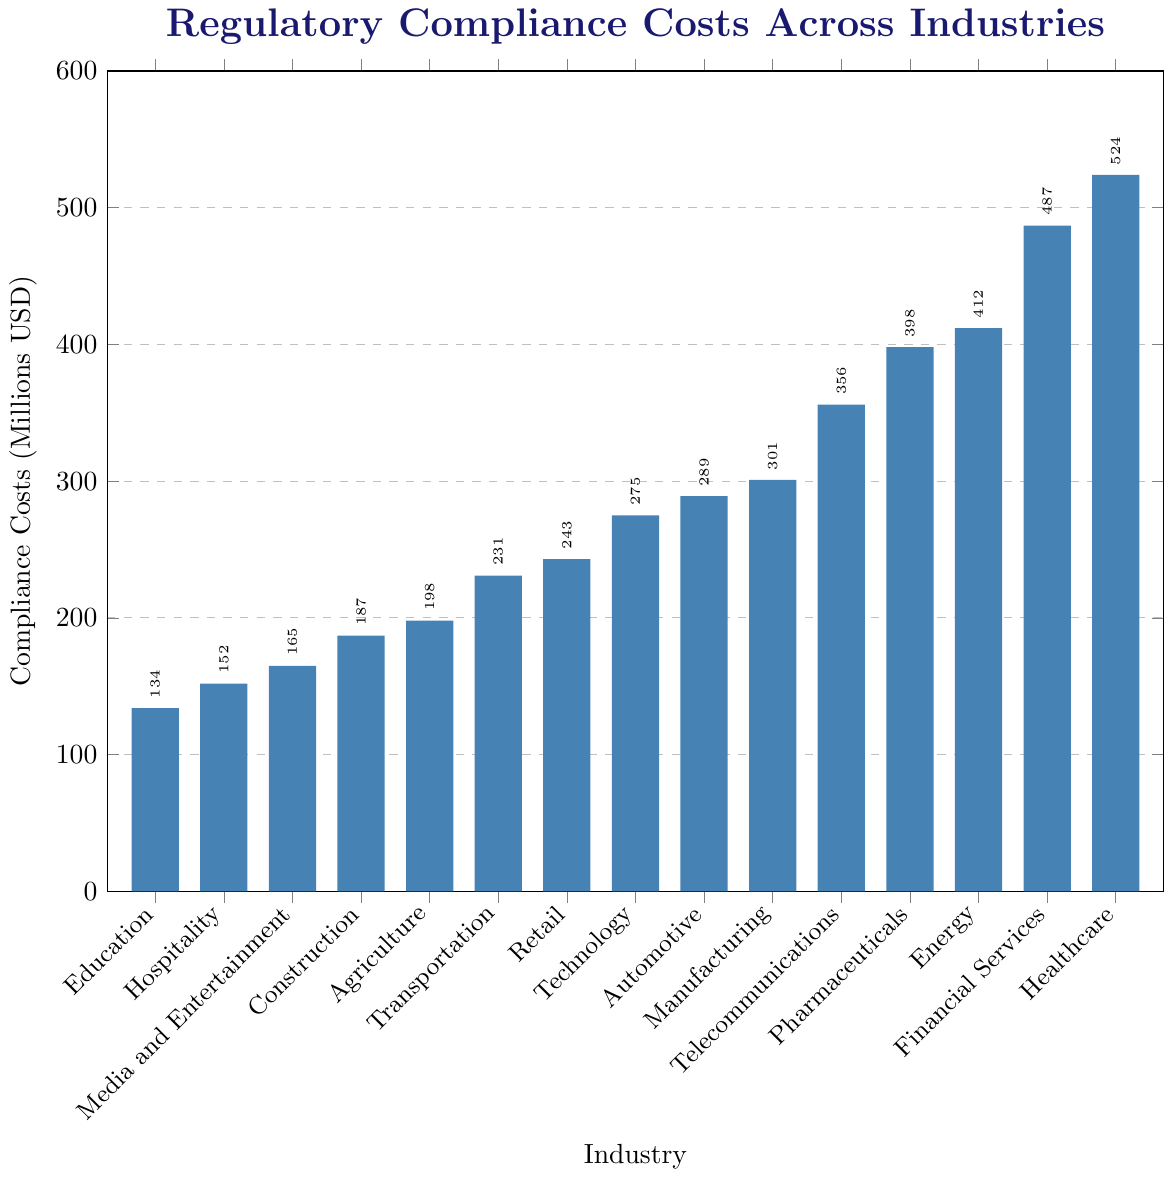Which industry has the highest regulatory compliance cost? The industry with the highest bar represents the highest compliance cost. Based on the chart, the Healthcare industry has the highest bar.
Answer: Healthcare What is the difference in regulatory compliance costs between the Financial Services and Telecommunications industries? The Financial Services industry has a compliance cost of 487 million USD, and the Telecommunications industry has 356 million USD. The difference is 487 - 356 = 131 million USD.
Answer: 131 million USD Which industry has the lowest regulatory compliance cost, and what is its value? The industry with the shortest bar represents the lowest compliance cost. Based on the chart, the Education industry has the lowest bar with a cost of 134 million USD.
Answer: Education with 134 million USD What is the sum of compliance costs for the Energy, Pharmaceuticals, and Telecommunications industries? The compliance costs for Energy, Pharmaceuticals, and Telecommunications are 412, 398, and 356 million USD respectively. The sum is 412 + 398 + 356 = 1166 million USD.
Answer: 1166 million USD How much higher are the compliance costs for the Healthcare industry compared to the Automotive industry? The Healthcare industry has a compliance cost of 524 million USD, and the Automotive industry has 289 million USD. The difference is 524 - 289 = 235 million USD.
Answer: 235 million USD Which industries have compliance costs greater than 400 million USD? The bars that exceed the 400 mark on the y-axis represent the industries with costs greater than 400 million USD. These industries are Healthcare (524 million USD), Financial Services (487 million USD), and Energy (412 million USD).
Answer: Healthcare, Financial Services, Energy What is the median compliance cost among all the industries listed? There are 15 industries. Ordering the compliance costs from lowest to highest: 134, 152, 165, 187, 198, 231, 243, 275, 289, 301, 356, 398, 412, 487, 524. The middle value (8th value) is the median. The sorted list shows 275 million USD as the median.
Answer: 275 million USD Are the compliance costs for the Technology industry higher or lower than those for the Manufacturing industry? The Technology industry has compliance costs of 275 million USD, and the Manufacturing industry has 301 million USD. Since 275 < 301, Technology has lower compliance costs.
Answer: Lower What is the average compliance cost across all listed industries? Sum all compliance costs: 134 + 152 + 165 + 187 + 198 + 231 + 243 + 275 + 289 + 301 + 356 + 398 + 412 + 487 + 524 = 4852 million USD. There are 15 industries. The average is 4852 / 15 ≈ 323.47 million USD.
Answer: Approximately 323.47 million USD How many industries have compliance costs in the range of 200 to 300 million USD? From the chart, the industries with costs 200 to 300 million USD are Transportation (231), Retail (243), Technology (275), and Automotive (289).
Answer: 4 